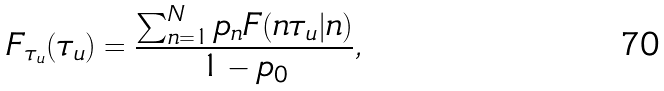Convert formula to latex. <formula><loc_0><loc_0><loc_500><loc_500>F _ { \tau _ { u } } ( \tau _ { u } ) = \frac { \sum _ { n = 1 } ^ { N } p _ { n } F ( n \tau _ { u } | n ) } { 1 - p _ { 0 } } ,</formula> 